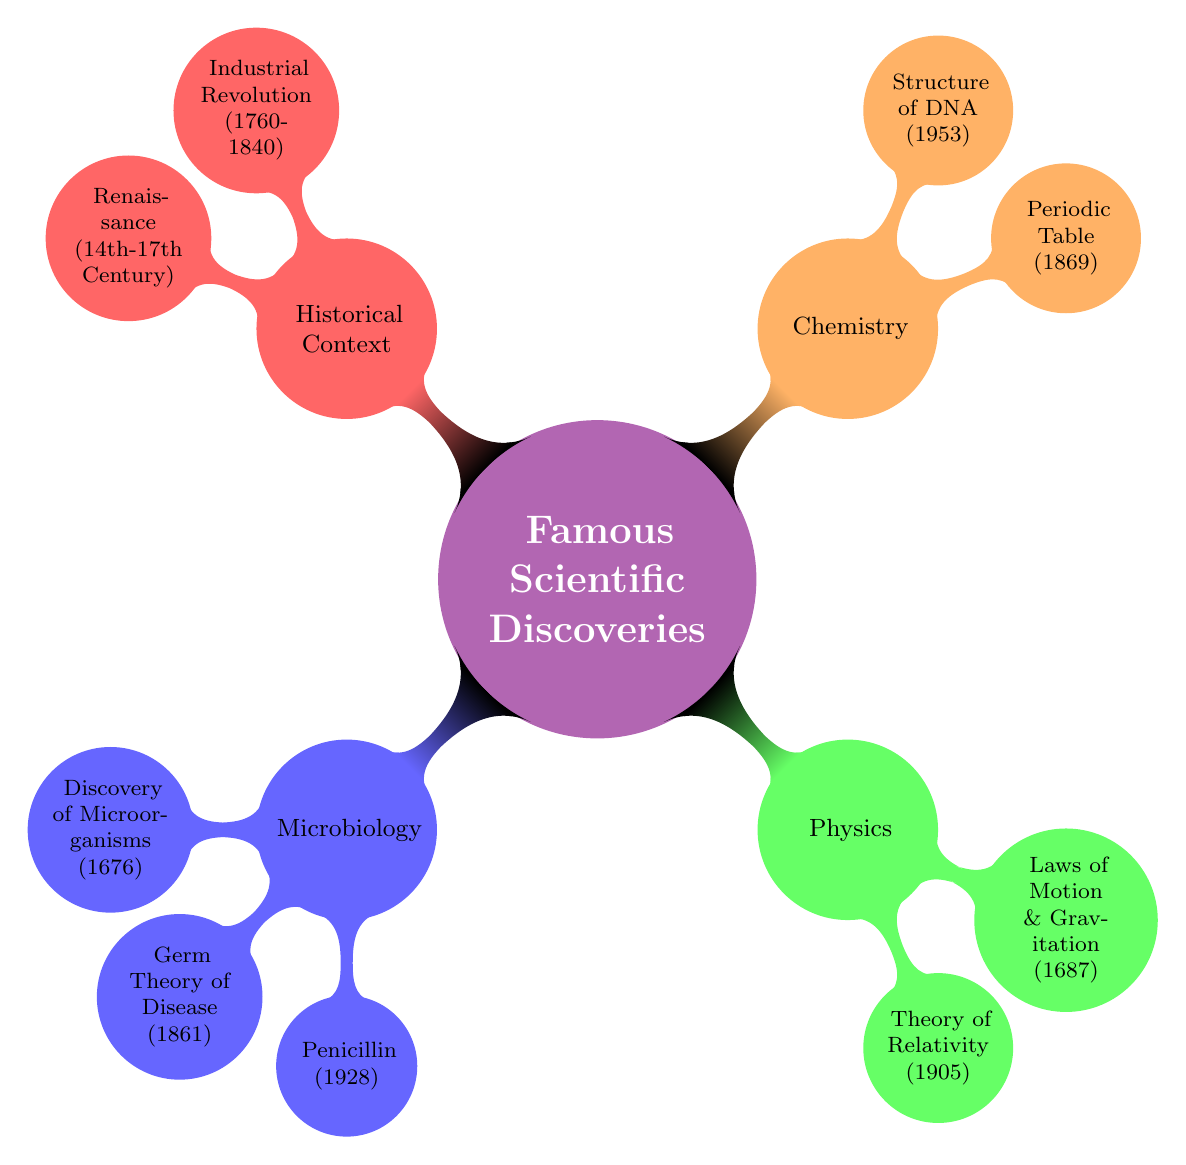What is the year of the discovery of Penicillin? The diagram shows that the discovery of Penicillin was made in the year 1928, which is directly listed under the Microbiology subtopic.
Answer: 1928 Who is the scientist associated with the Germ Theory of Disease? The diagram indicates that Louis Pasteur is the scientist who formulated the Germ Theory of Disease, mentioned under the Key Discoveries in the Microbiology section.
Answer: Louis Pasteur How many key discoveries are listed in the Physics section? Counting the key discoveries listed under the Physics subtopic shows two: Theory of Relativity and Laws of Motion & Gravitation.
Answer: 2 What period did the Industrial Revolution occur? The diagram states that the Industrial Revolution took place between the years 1760-1840, shown under the Historical Context section.
Answer: 1760-1840 Which scientist discovered the Structure of DNA? The investigation of the Chemistry subtopic reveals that the Structure of DNA was discovered by James Watson and Francis Crick, as indicated in the Key Discoveries.
Answer: James Watson and Francis Crick What impact did the Renaissance have on science? According to the diagram, the Renaissance is indicated to have greatly contributed to scientific inquiry and the rise of modern science, summarizing its impact in a sentence under Historical Context.
Answer: Greatly contributed to scientific inquiry and the rise of modern science In which field did Antonie van Leeuwenhoek make a discovery? The diagram categorizes Antonie van Leeuwenhoek’s discovery of microorganisms under the Microbiology subtopic.
Answer: Microbiology What is the fundamental tool in Chemistry introduced by Dmitri Mendeleev? The diagram illustrates that the Periodic Table is the fundamental tool in Chemistry that was introduced by Dmitri Mendeleev in 1869.
Answer: Periodic Table Describe the impact of the Theory of Relativity. The diagram notes that the Theory of Relativity changed the understanding of time, space, and gravity, with significant influence on modern physics and cosmology, requiring synthesizing information across the Physics subtopic.
Answer: Changed the understanding of time, space, and gravity 